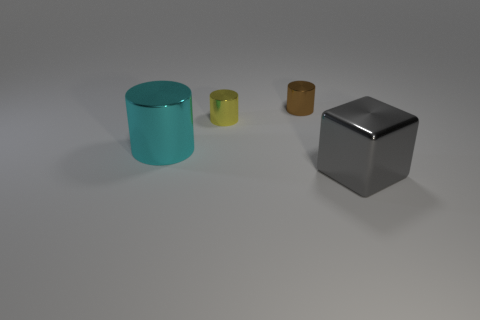What material is the object that is in front of the small yellow object and on the left side of the big gray metallic thing?
Ensure brevity in your answer.  Metal. There is a big shiny thing on the left side of the big shiny thing that is in front of the big metallic object that is left of the brown metallic cylinder; what is its color?
Offer a very short reply. Cyan. What color is the other object that is the same size as the brown object?
Your response must be concise. Yellow. What material is the large thing that is behind the large thing that is to the right of the small brown object?
Your answer should be compact. Metal. How many small shiny cylinders are both in front of the tiny brown object and right of the small yellow thing?
Keep it short and to the point. 0. What number of other things are there of the same size as the gray thing?
Make the answer very short. 1. There is a metal thing left of the tiny yellow cylinder; is it the same shape as the metallic thing that is behind the small yellow cylinder?
Provide a succinct answer. Yes. Are there any tiny things behind the large shiny cylinder?
Give a very brief answer. Yes. There is another tiny metal object that is the same shape as the yellow object; what color is it?
Provide a succinct answer. Brown. Is there any other thing that is the same shape as the gray metallic thing?
Keep it short and to the point. No. 